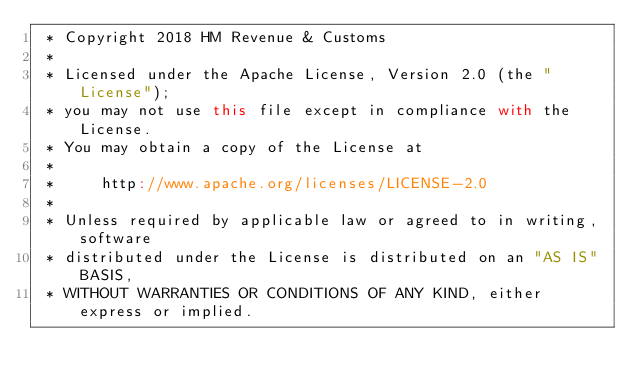<code> <loc_0><loc_0><loc_500><loc_500><_Scala_> * Copyright 2018 HM Revenue & Customs
 *
 * Licensed under the Apache License, Version 2.0 (the "License");
 * you may not use this file except in compliance with the License.
 * You may obtain a copy of the License at
 *
 *     http://www.apache.org/licenses/LICENSE-2.0
 *
 * Unless required by applicable law or agreed to in writing, software
 * distributed under the License is distributed on an "AS IS" BASIS,
 * WITHOUT WARRANTIES OR CONDITIONS OF ANY KIND, either express or implied.</code> 